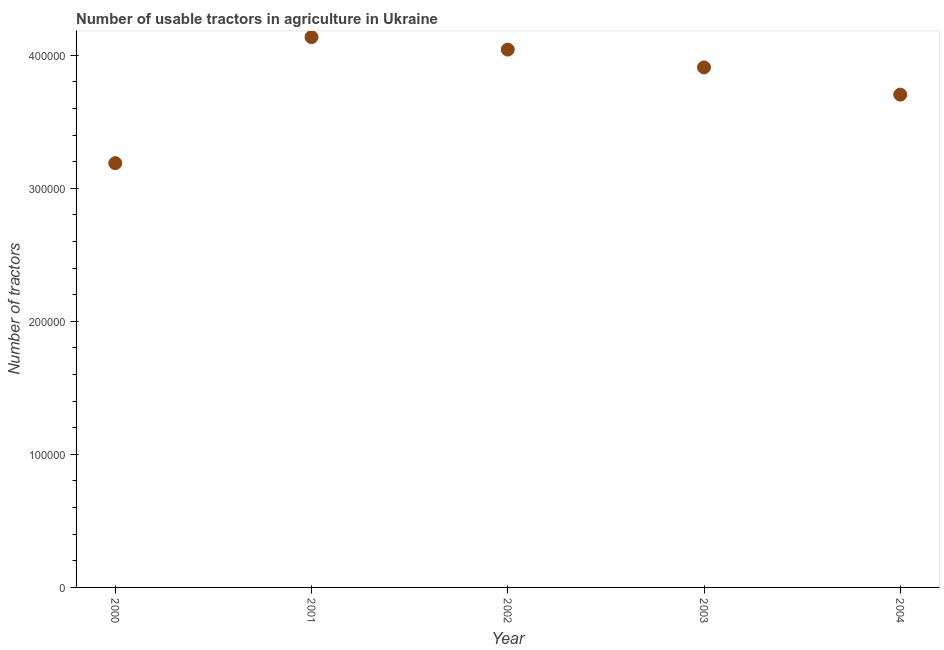What is the number of tractors in 2004?
Keep it short and to the point. 3.70e+05. Across all years, what is the maximum number of tractors?
Give a very brief answer. 4.14e+05. Across all years, what is the minimum number of tractors?
Ensure brevity in your answer.  3.19e+05. What is the sum of the number of tractors?
Give a very brief answer. 1.90e+06. What is the difference between the number of tractors in 2003 and 2004?
Provide a short and direct response. 2.04e+04. What is the average number of tractors per year?
Offer a very short reply. 3.80e+05. What is the median number of tractors?
Make the answer very short. 3.91e+05. In how many years, is the number of tractors greater than 240000 ?
Your answer should be compact. 5. Do a majority of the years between 2000 and 2002 (inclusive) have number of tractors greater than 220000 ?
Provide a succinct answer. Yes. What is the ratio of the number of tractors in 2000 to that in 2003?
Your response must be concise. 0.82. Is the number of tractors in 2001 less than that in 2004?
Offer a terse response. No. What is the difference between the highest and the second highest number of tractors?
Your answer should be very brief. 9366. Is the sum of the number of tractors in 2001 and 2002 greater than the maximum number of tractors across all years?
Make the answer very short. Yes. What is the difference between the highest and the lowest number of tractors?
Provide a succinct answer. 9.47e+04. How many years are there in the graph?
Offer a terse response. 5. What is the difference between two consecutive major ticks on the Y-axis?
Make the answer very short. 1.00e+05. Are the values on the major ticks of Y-axis written in scientific E-notation?
Offer a terse response. No. Does the graph contain any zero values?
Your answer should be compact. No. Does the graph contain grids?
Provide a short and direct response. No. What is the title of the graph?
Give a very brief answer. Number of usable tractors in agriculture in Ukraine. What is the label or title of the Y-axis?
Provide a short and direct response. Number of tractors. What is the Number of tractors in 2000?
Your answer should be compact. 3.19e+05. What is the Number of tractors in 2001?
Give a very brief answer. 4.14e+05. What is the Number of tractors in 2002?
Make the answer very short. 4.04e+05. What is the Number of tractors in 2003?
Your response must be concise. 3.91e+05. What is the Number of tractors in 2004?
Your answer should be very brief. 3.70e+05. What is the difference between the Number of tractors in 2000 and 2001?
Your answer should be very brief. -9.47e+04. What is the difference between the Number of tractors in 2000 and 2002?
Give a very brief answer. -8.54e+04. What is the difference between the Number of tractors in 2000 and 2003?
Provide a short and direct response. -7.19e+04. What is the difference between the Number of tractors in 2000 and 2004?
Keep it short and to the point. -5.15e+04. What is the difference between the Number of tractors in 2001 and 2002?
Make the answer very short. 9366. What is the difference between the Number of tractors in 2001 and 2003?
Ensure brevity in your answer.  2.28e+04. What is the difference between the Number of tractors in 2001 and 2004?
Ensure brevity in your answer.  4.32e+04. What is the difference between the Number of tractors in 2002 and 2003?
Your response must be concise. 1.34e+04. What is the difference between the Number of tractors in 2002 and 2004?
Your answer should be compact. 3.39e+04. What is the difference between the Number of tractors in 2003 and 2004?
Your answer should be compact. 2.04e+04. What is the ratio of the Number of tractors in 2000 to that in 2001?
Ensure brevity in your answer.  0.77. What is the ratio of the Number of tractors in 2000 to that in 2002?
Give a very brief answer. 0.79. What is the ratio of the Number of tractors in 2000 to that in 2003?
Give a very brief answer. 0.82. What is the ratio of the Number of tractors in 2000 to that in 2004?
Your answer should be compact. 0.86. What is the ratio of the Number of tractors in 2001 to that in 2003?
Give a very brief answer. 1.06. What is the ratio of the Number of tractors in 2001 to that in 2004?
Ensure brevity in your answer.  1.12. What is the ratio of the Number of tractors in 2002 to that in 2003?
Offer a terse response. 1.03. What is the ratio of the Number of tractors in 2002 to that in 2004?
Make the answer very short. 1.09. What is the ratio of the Number of tractors in 2003 to that in 2004?
Offer a very short reply. 1.05. 